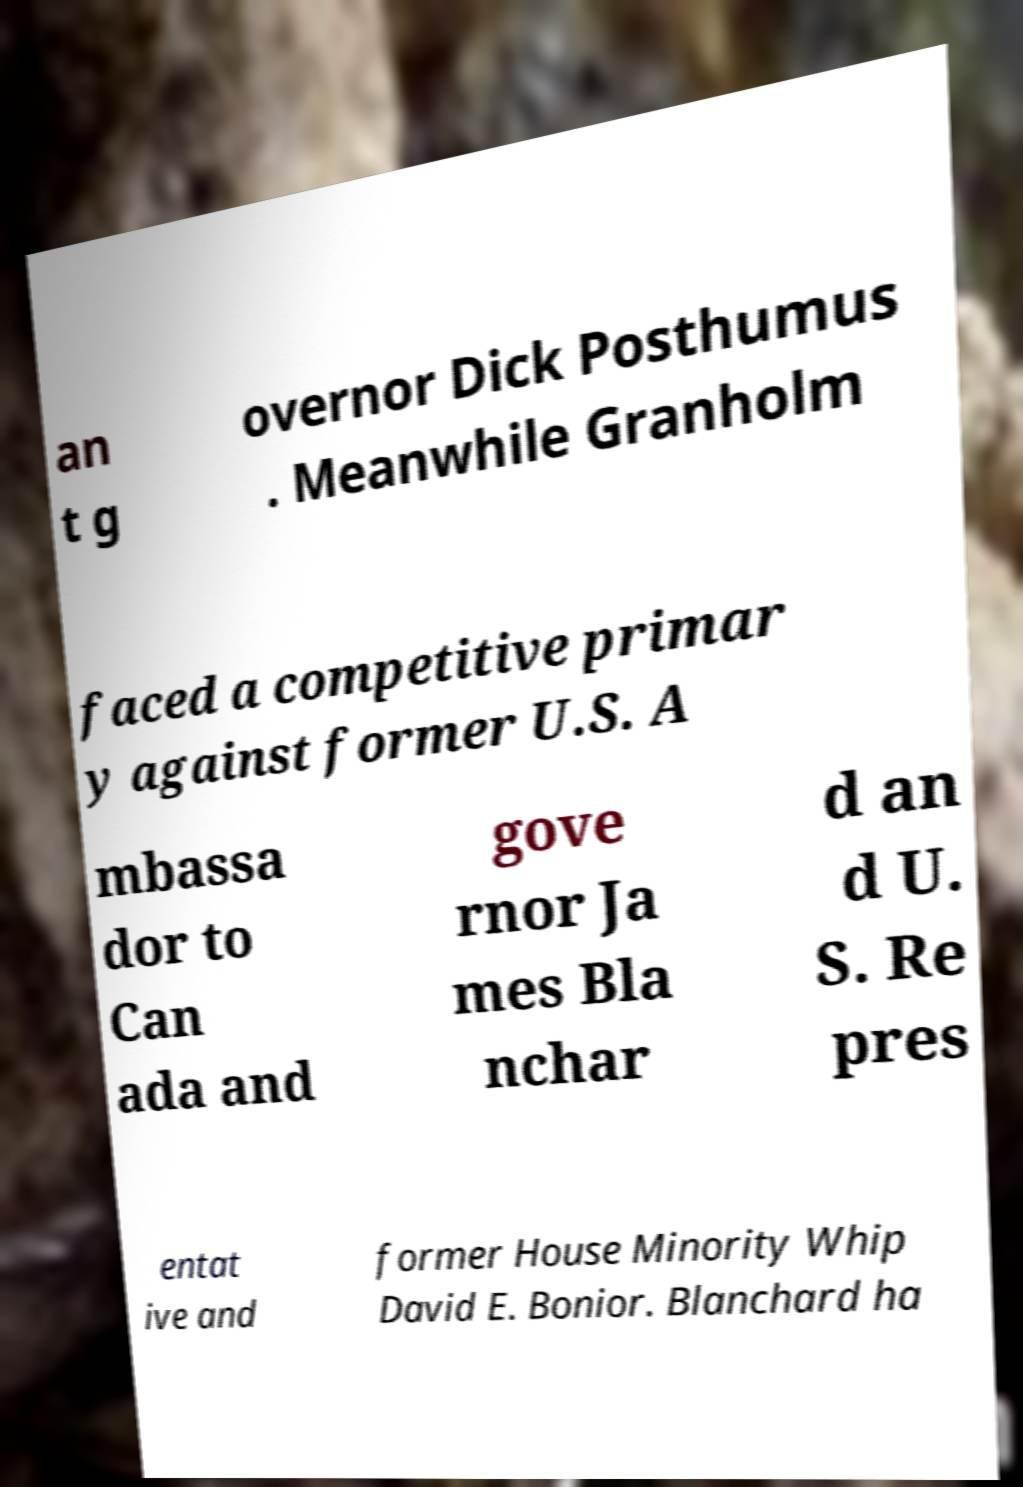I need the written content from this picture converted into text. Can you do that? an t g overnor Dick Posthumus . Meanwhile Granholm faced a competitive primar y against former U.S. A mbassa dor to Can ada and gove rnor Ja mes Bla nchar d an d U. S. Re pres entat ive and former House Minority Whip David E. Bonior. Blanchard ha 